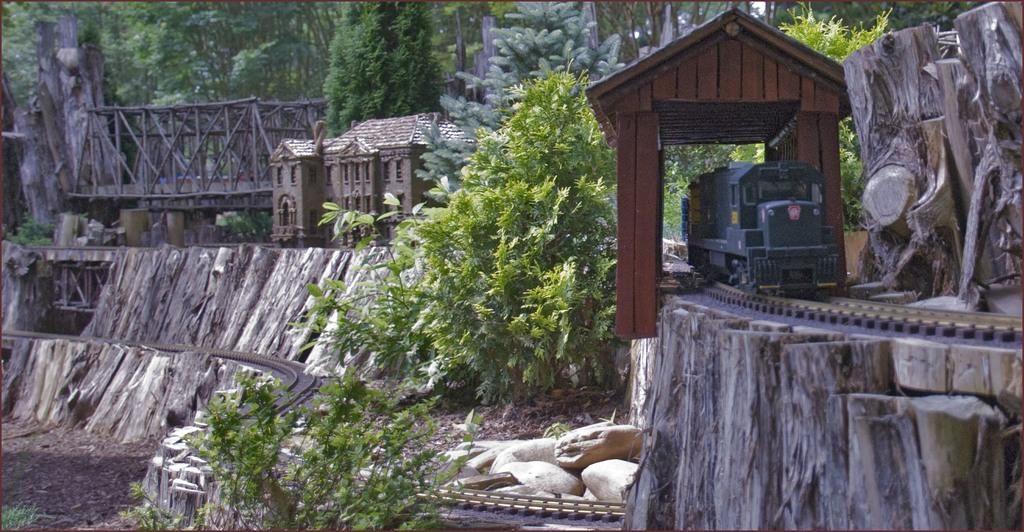What type of structure is visible in the image? There is a house in the image. What other man-made structure can be seen in the image? There is a bridge in the image. What mode of transportation is present in the image? There is a train in the image. What is the train traveling on? There is a railway track in the image. What type of natural elements are present in the image? There are plants, bark, stones, and trees in the image. Where is the church located in the image? There is no church present in the image. What is the chance of winning a prize in the image? There is no mention of a prize or chance in the image. 